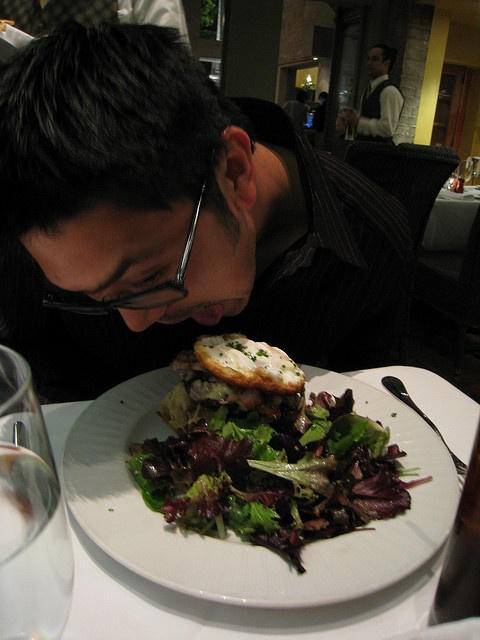Describe the objects in this image and their specific colors. I can see people in black, maroon, and gray tones, dining table in black, lightgray, gray, and darkgray tones, wine glass in black, gray, lightgray, and darkgray tones, sandwich in black, maroon, olive, and tan tones, and people in darkgray, black, and gray tones in this image. 